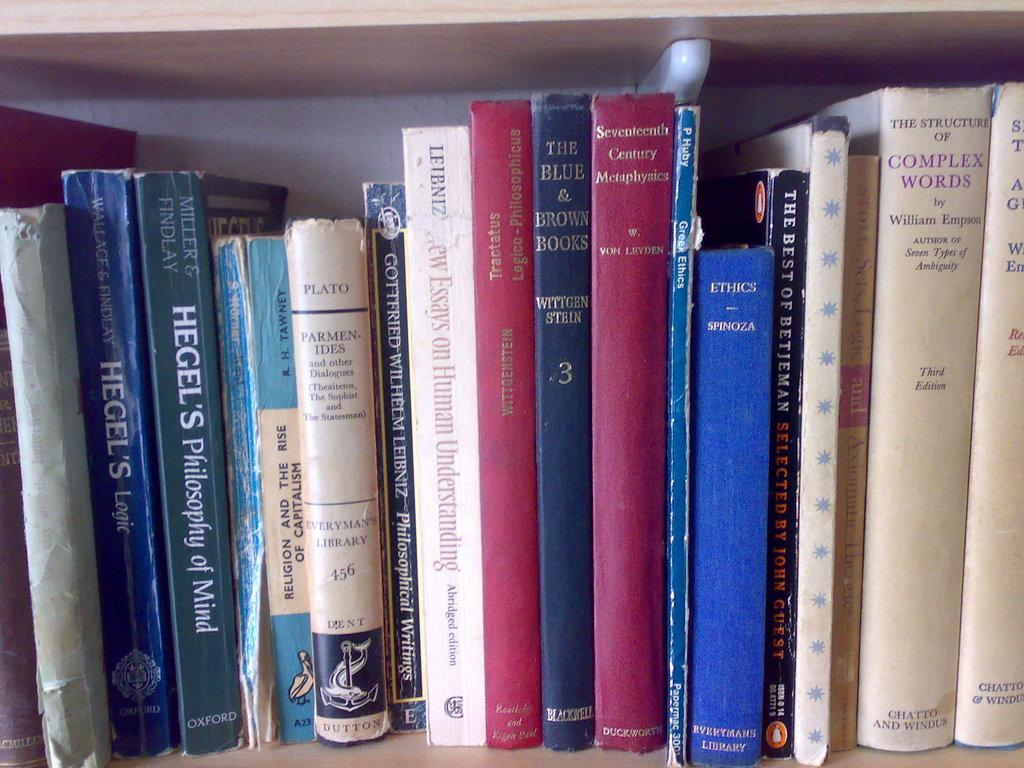<image>
Provide a brief description of the given image. Of all the books lined up on the shelf, the Hegel's books stand out the most. 